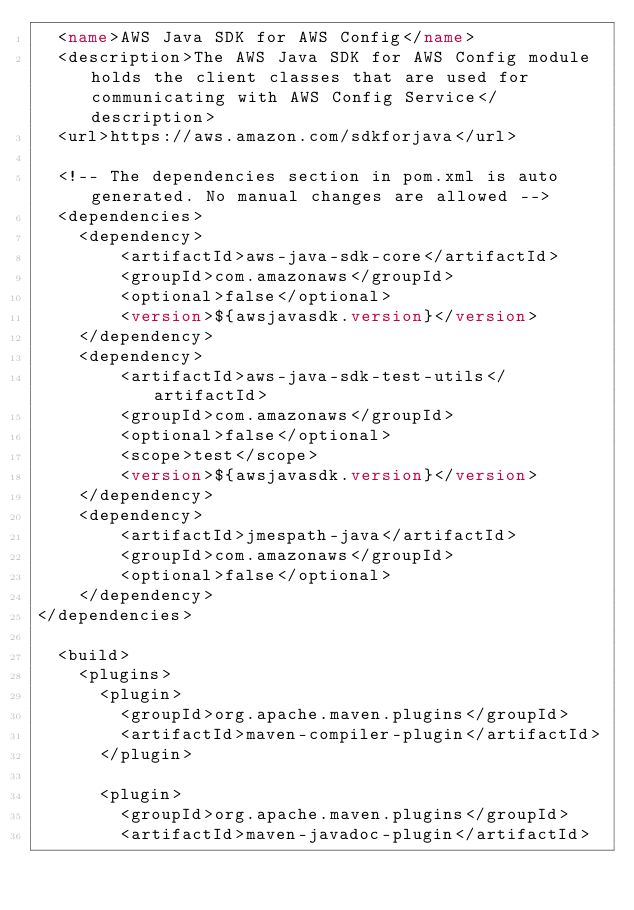<code> <loc_0><loc_0><loc_500><loc_500><_XML_>  <name>AWS Java SDK for AWS Config</name>
  <description>The AWS Java SDK for AWS Config module holds the client classes that are used for communicating with AWS Config Service</description>
  <url>https://aws.amazon.com/sdkforjava</url>

  <!-- The dependencies section in pom.xml is auto generated. No manual changes are allowed -->
  <dependencies>
    <dependency>
        <artifactId>aws-java-sdk-core</artifactId>
        <groupId>com.amazonaws</groupId>
        <optional>false</optional>
        <version>${awsjavasdk.version}</version>
    </dependency>
    <dependency>
        <artifactId>aws-java-sdk-test-utils</artifactId>
        <groupId>com.amazonaws</groupId>
        <optional>false</optional>
        <scope>test</scope>
        <version>${awsjavasdk.version}</version>
    </dependency>
    <dependency>
        <artifactId>jmespath-java</artifactId>
        <groupId>com.amazonaws</groupId>
        <optional>false</optional>
    </dependency>
</dependencies>

  <build>
    <plugins>
      <plugin>
        <groupId>org.apache.maven.plugins</groupId>
        <artifactId>maven-compiler-plugin</artifactId>
      </plugin>

      <plugin>
        <groupId>org.apache.maven.plugins</groupId>
        <artifactId>maven-javadoc-plugin</artifactId></code> 